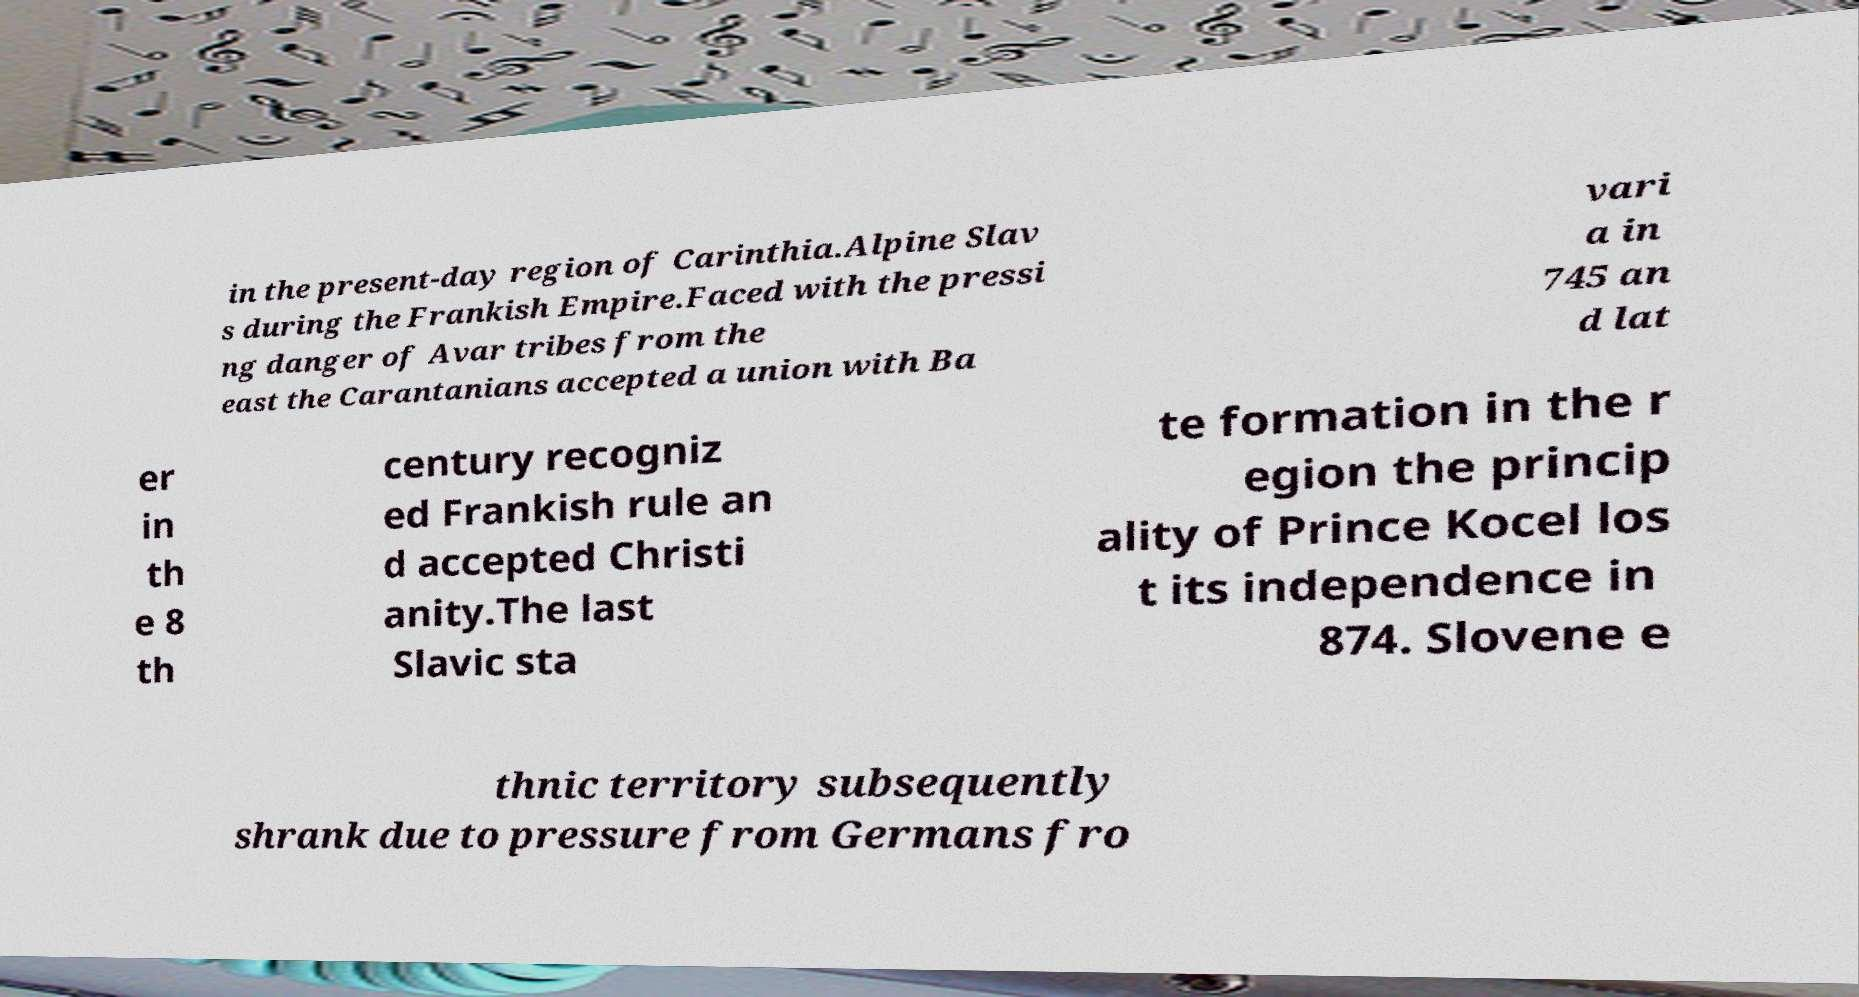Could you assist in decoding the text presented in this image and type it out clearly? in the present-day region of Carinthia.Alpine Slav s during the Frankish Empire.Faced with the pressi ng danger of Avar tribes from the east the Carantanians accepted a union with Ba vari a in 745 an d lat er in th e 8 th century recogniz ed Frankish rule an d accepted Christi anity.The last Slavic sta te formation in the r egion the princip ality of Prince Kocel los t its independence in 874. Slovene e thnic territory subsequently shrank due to pressure from Germans fro 